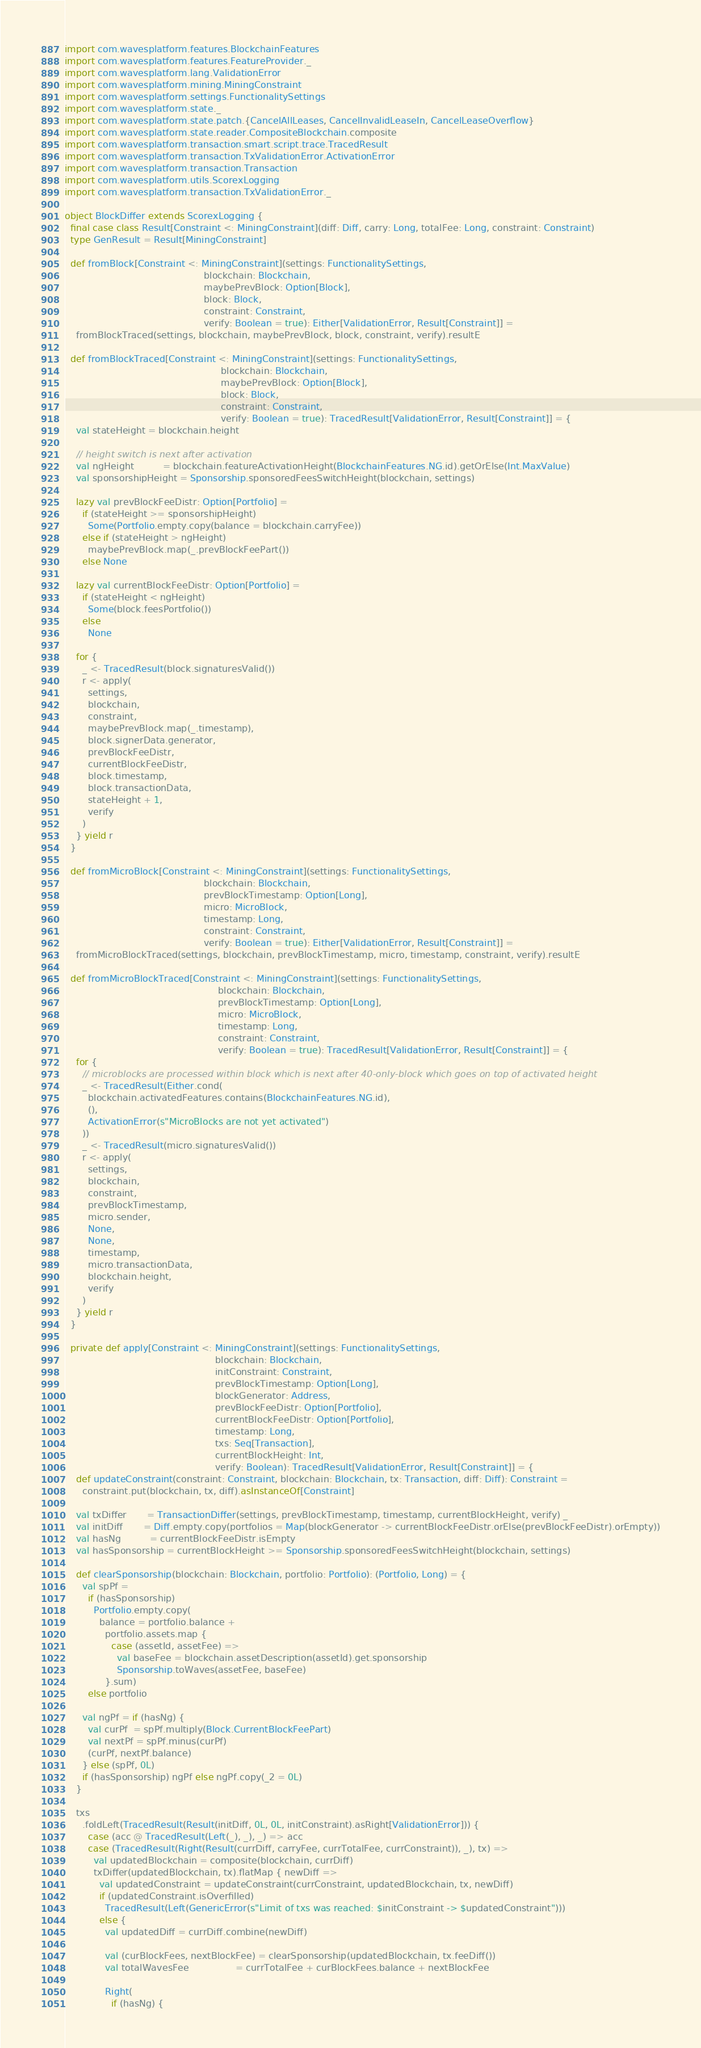<code> <loc_0><loc_0><loc_500><loc_500><_Scala_>import com.wavesplatform.features.BlockchainFeatures
import com.wavesplatform.features.FeatureProvider._
import com.wavesplatform.lang.ValidationError
import com.wavesplatform.mining.MiningConstraint
import com.wavesplatform.settings.FunctionalitySettings
import com.wavesplatform.state._
import com.wavesplatform.state.patch.{CancelAllLeases, CancelInvalidLeaseIn, CancelLeaseOverflow}
import com.wavesplatform.state.reader.CompositeBlockchain.composite
import com.wavesplatform.transaction.smart.script.trace.TracedResult
import com.wavesplatform.transaction.TxValidationError.ActivationError
import com.wavesplatform.transaction.Transaction
import com.wavesplatform.utils.ScorexLogging
import com.wavesplatform.transaction.TxValidationError._

object BlockDiffer extends ScorexLogging {
  final case class Result[Constraint <: MiningConstraint](diff: Diff, carry: Long, totalFee: Long, constraint: Constraint)
  type GenResult = Result[MiningConstraint]

  def fromBlock[Constraint <: MiningConstraint](settings: FunctionalitySettings,
                                                blockchain: Blockchain,
                                                maybePrevBlock: Option[Block],
                                                block: Block,
                                                constraint: Constraint,
                                                verify: Boolean = true): Either[ValidationError, Result[Constraint]] =
    fromBlockTraced(settings, blockchain, maybePrevBlock, block, constraint, verify).resultE

  def fromBlockTraced[Constraint <: MiningConstraint](settings: FunctionalitySettings,
                                                      blockchain: Blockchain,
                                                      maybePrevBlock: Option[Block],
                                                      block: Block,
                                                      constraint: Constraint,
                                                      verify: Boolean = true): TracedResult[ValidationError, Result[Constraint]] = {
    val stateHeight = blockchain.height

    // height switch is next after activation
    val ngHeight          = blockchain.featureActivationHeight(BlockchainFeatures.NG.id).getOrElse(Int.MaxValue)
    val sponsorshipHeight = Sponsorship.sponsoredFeesSwitchHeight(blockchain, settings)

    lazy val prevBlockFeeDistr: Option[Portfolio] =
      if (stateHeight >= sponsorshipHeight)
        Some(Portfolio.empty.copy(balance = blockchain.carryFee))
      else if (stateHeight > ngHeight)
        maybePrevBlock.map(_.prevBlockFeePart())
      else None

    lazy val currentBlockFeeDistr: Option[Portfolio] =
      if (stateHeight < ngHeight)
        Some(block.feesPortfolio())
      else
        None

    for {
      _ <- TracedResult(block.signaturesValid())
      r <- apply(
        settings,
        blockchain,
        constraint,
        maybePrevBlock.map(_.timestamp),
        block.signerData.generator,
        prevBlockFeeDistr,
        currentBlockFeeDistr,
        block.timestamp,
        block.transactionData,
        stateHeight + 1,
        verify
      )
    } yield r
  }

  def fromMicroBlock[Constraint <: MiningConstraint](settings: FunctionalitySettings,
                                                blockchain: Blockchain,
                                                prevBlockTimestamp: Option[Long],
                                                micro: MicroBlock,
                                                timestamp: Long,
                                                constraint: Constraint,
                                                verify: Boolean = true): Either[ValidationError, Result[Constraint]] =
    fromMicroBlockTraced(settings, blockchain, prevBlockTimestamp, micro, timestamp, constraint, verify).resultE

  def fromMicroBlockTraced[Constraint <: MiningConstraint](settings: FunctionalitySettings,
                                                     blockchain: Blockchain,
                                                     prevBlockTimestamp: Option[Long],
                                                     micro: MicroBlock,
                                                     timestamp: Long,
                                                     constraint: Constraint,
                                                     verify: Boolean = true): TracedResult[ValidationError, Result[Constraint]] = {
    for {
      // microblocks are processed within block which is next after 40-only-block which goes on top of activated height
      _ <- TracedResult(Either.cond(
        blockchain.activatedFeatures.contains(BlockchainFeatures.NG.id),
        (),
        ActivationError(s"MicroBlocks are not yet activated")
      ))
      _ <- TracedResult(micro.signaturesValid())
      r <- apply(
        settings,
        blockchain,
        constraint,
        prevBlockTimestamp,
        micro.sender,
        None,
        None,
        timestamp,
        micro.transactionData,
        blockchain.height,
        verify
      )
    } yield r
  }

  private def apply[Constraint <: MiningConstraint](settings: FunctionalitySettings,
                                                    blockchain: Blockchain,
                                                    initConstraint: Constraint,
                                                    prevBlockTimestamp: Option[Long],
                                                    blockGenerator: Address,
                                                    prevBlockFeeDistr: Option[Portfolio],
                                                    currentBlockFeeDistr: Option[Portfolio],
                                                    timestamp: Long,
                                                    txs: Seq[Transaction],
                                                    currentBlockHeight: Int,
                                                    verify: Boolean): TracedResult[ValidationError, Result[Constraint]] = {
    def updateConstraint(constraint: Constraint, blockchain: Blockchain, tx: Transaction, diff: Diff): Constraint =
      constraint.put(blockchain, tx, diff).asInstanceOf[Constraint]

    val txDiffer       = TransactionDiffer(settings, prevBlockTimestamp, timestamp, currentBlockHeight, verify) _
    val initDiff       = Diff.empty.copy(portfolios = Map(blockGenerator -> currentBlockFeeDistr.orElse(prevBlockFeeDistr).orEmpty))
    val hasNg          = currentBlockFeeDistr.isEmpty
    val hasSponsorship = currentBlockHeight >= Sponsorship.sponsoredFeesSwitchHeight(blockchain, settings)

    def clearSponsorship(blockchain: Blockchain, portfolio: Portfolio): (Portfolio, Long) = {
      val spPf =
        if (hasSponsorship)
          Portfolio.empty.copy(
            balance = portfolio.balance +
              portfolio.assets.map {
                case (assetId, assetFee) =>
                  val baseFee = blockchain.assetDescription(assetId).get.sponsorship
                  Sponsorship.toWaves(assetFee, baseFee)
              }.sum)
        else portfolio

      val ngPf = if (hasNg) {
        val curPf  = spPf.multiply(Block.CurrentBlockFeePart)
        val nextPf = spPf.minus(curPf)
        (curPf, nextPf.balance)
      } else (spPf, 0L)
      if (hasSponsorship) ngPf else ngPf.copy(_2 = 0L)
    }

    txs
      .foldLeft(TracedResult(Result(initDiff, 0L, 0L, initConstraint).asRight[ValidationError])) {
        case (acc @ TracedResult(Left(_), _), _) => acc
        case (TracedResult(Right(Result(currDiff, carryFee, currTotalFee, currConstraint)), _), tx) =>
          val updatedBlockchain = composite(blockchain, currDiff)
          txDiffer(updatedBlockchain, tx).flatMap { newDiff =>
            val updatedConstraint = updateConstraint(currConstraint, updatedBlockchain, tx, newDiff)
            if (updatedConstraint.isOverfilled)
              TracedResult(Left(GenericError(s"Limit of txs was reached: $initConstraint -> $updatedConstraint")))
            else {
              val updatedDiff = currDiff.combine(newDiff)

              val (curBlockFees, nextBlockFee) = clearSponsorship(updatedBlockchain, tx.feeDiff())
              val totalWavesFee                = currTotalFee + curBlockFees.balance + nextBlockFee

              Right(
                if (hasNg) {</code> 